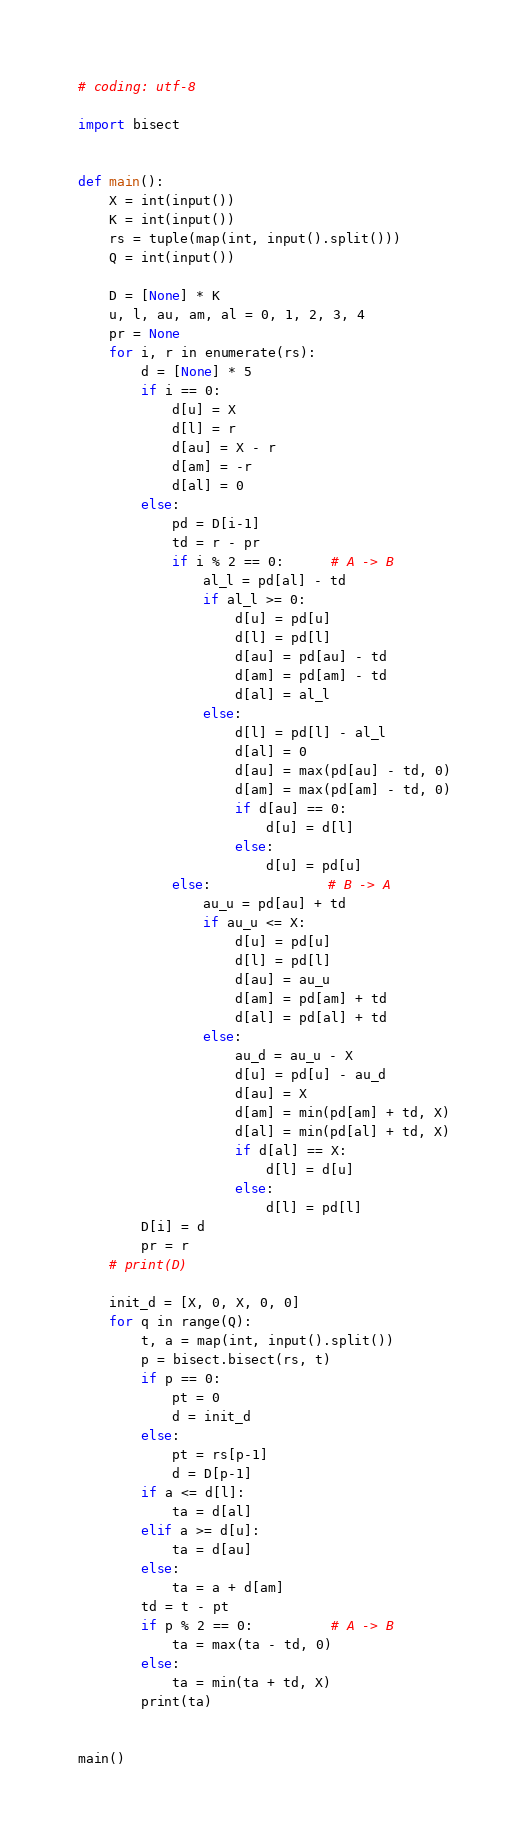<code> <loc_0><loc_0><loc_500><loc_500><_Python_># coding: utf-8

import bisect


def main():
    X = int(input())
    K = int(input())
    rs = tuple(map(int, input().split()))
    Q = int(input())

    D = [None] * K
    u, l, au, am, al = 0, 1, 2, 3, 4
    pr = None
    for i, r in enumerate(rs):
        d = [None] * 5
        if i == 0:
            d[u] = X
            d[l] = r
            d[au] = X - r
            d[am] = -r
            d[al] = 0
        else:
            pd = D[i-1]
            td = r - pr
            if i % 2 == 0:      # A -> B
                al_l = pd[al] - td
                if al_l >= 0:
                    d[u] = pd[u]
                    d[l] = pd[l]
                    d[au] = pd[au] - td
                    d[am] = pd[am] - td
                    d[al] = al_l
                else:
                    d[l] = pd[l] - al_l
                    d[al] = 0
                    d[au] = max(pd[au] - td, 0)
                    d[am] = max(pd[am] - td, 0)
                    if d[au] == 0:
                        d[u] = d[l]
                    else:
                        d[u] = pd[u]
            else:               # B -> A
                au_u = pd[au] + td
                if au_u <= X:
                    d[u] = pd[u]
                    d[l] = pd[l]
                    d[au] = au_u
                    d[am] = pd[am] + td
                    d[al] = pd[al] + td
                else:
                    au_d = au_u - X
                    d[u] = pd[u] - au_d
                    d[au] = X
                    d[am] = min(pd[am] + td, X)
                    d[al] = min(pd[al] + td, X)
                    if d[al] == X:
                        d[l] = d[u]
                    else:
                        d[l] = pd[l]
        D[i] = d
        pr = r
    # print(D)

    init_d = [X, 0, X, 0, 0]
    for q in range(Q):
        t, a = map(int, input().split())
        p = bisect.bisect(rs, t)
        if p == 0:
            pt = 0
            d = init_d
        else:
            pt = rs[p-1]
            d = D[p-1]
        if a <= d[l]:
            ta = d[al]
        elif a >= d[u]:
            ta = d[au]
        else:
            ta = a + d[am]
        td = t - pt
        if p % 2 == 0:          # A -> B
            ta = max(ta - td, 0)
        else:
            ta = min(ta + td, X)
        print(ta)


main()
</code> 